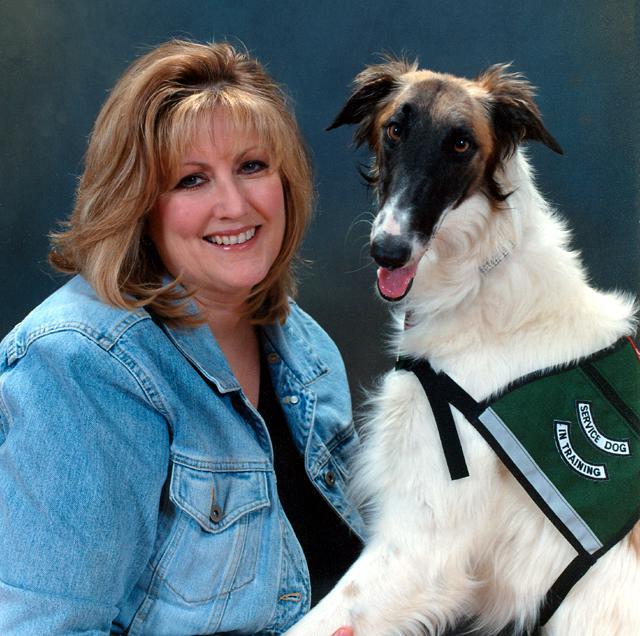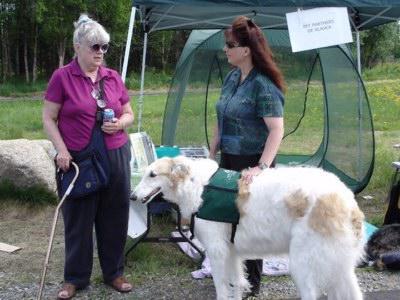The first image is the image on the left, the second image is the image on the right. Assess this claim about the two images: "There is a woman in a denim shirt touching a dog in one of the images.". Correct or not? Answer yes or no. Yes. The first image is the image on the left, the second image is the image on the right. For the images displayed, is the sentence "There is 1 dog facing left in both images." factually correct? Answer yes or no. Yes. 